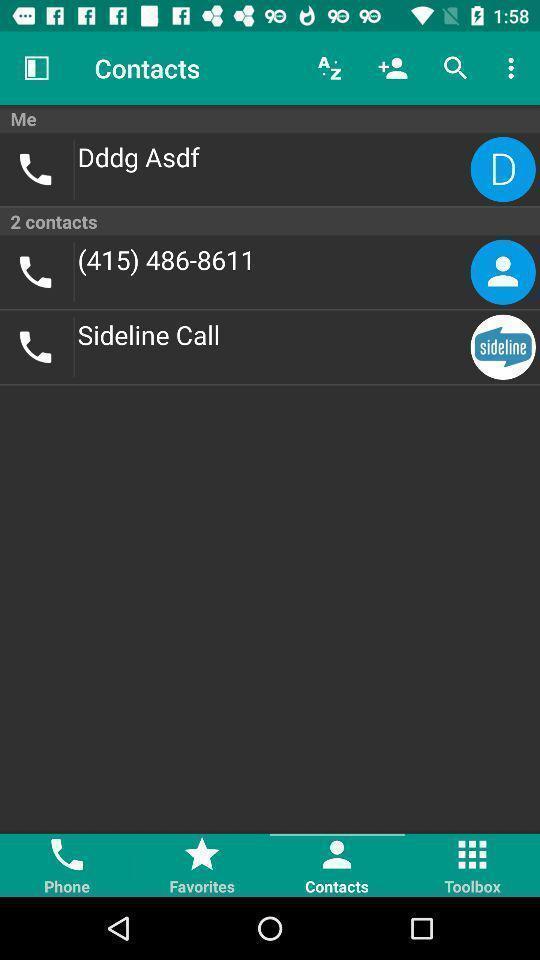Summarize the main components in this picture. Screen displaying the list of contact numbers. 